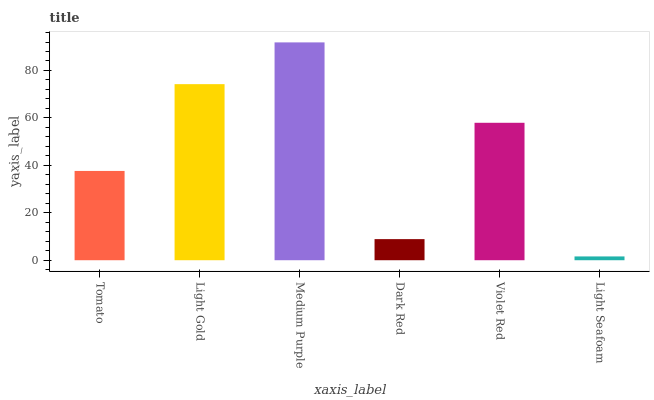Is Light Seafoam the minimum?
Answer yes or no. Yes. Is Medium Purple the maximum?
Answer yes or no. Yes. Is Light Gold the minimum?
Answer yes or no. No. Is Light Gold the maximum?
Answer yes or no. No. Is Light Gold greater than Tomato?
Answer yes or no. Yes. Is Tomato less than Light Gold?
Answer yes or no. Yes. Is Tomato greater than Light Gold?
Answer yes or no. No. Is Light Gold less than Tomato?
Answer yes or no. No. Is Violet Red the high median?
Answer yes or no. Yes. Is Tomato the low median?
Answer yes or no. Yes. Is Light Seafoam the high median?
Answer yes or no. No. Is Medium Purple the low median?
Answer yes or no. No. 